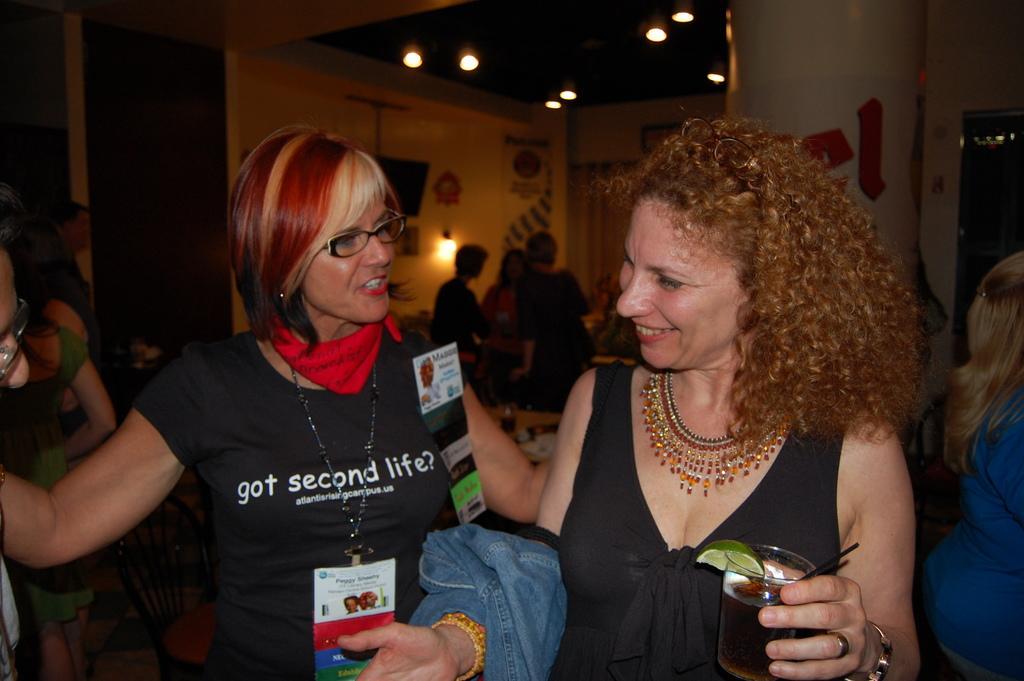Could you give a brief overview of what you see in this image? In this image we can see two ladies. One lady is wearing a tag and specs. Another lady is holding a glass. In the back there are many people. Also there is a pillar. On the ceiling there are lights. And there is a wall with light. On the wall some other things are there. 